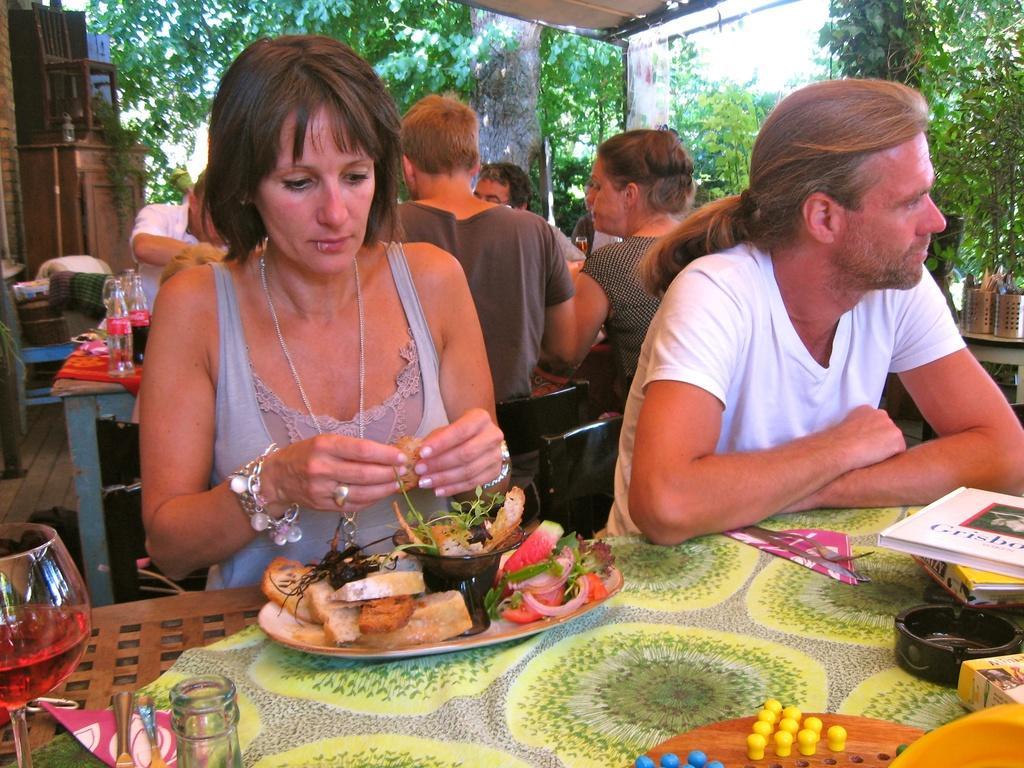Please provide a concise description of this image. In this image, there are a few people sitting. We can see some tables with objects like food items, glasses, bottles and some books. We can see the ground and some cloth. We can see a desk with a chair. We can see some objects on the right. There are a few trees. We can also see some objects at the bottom. 